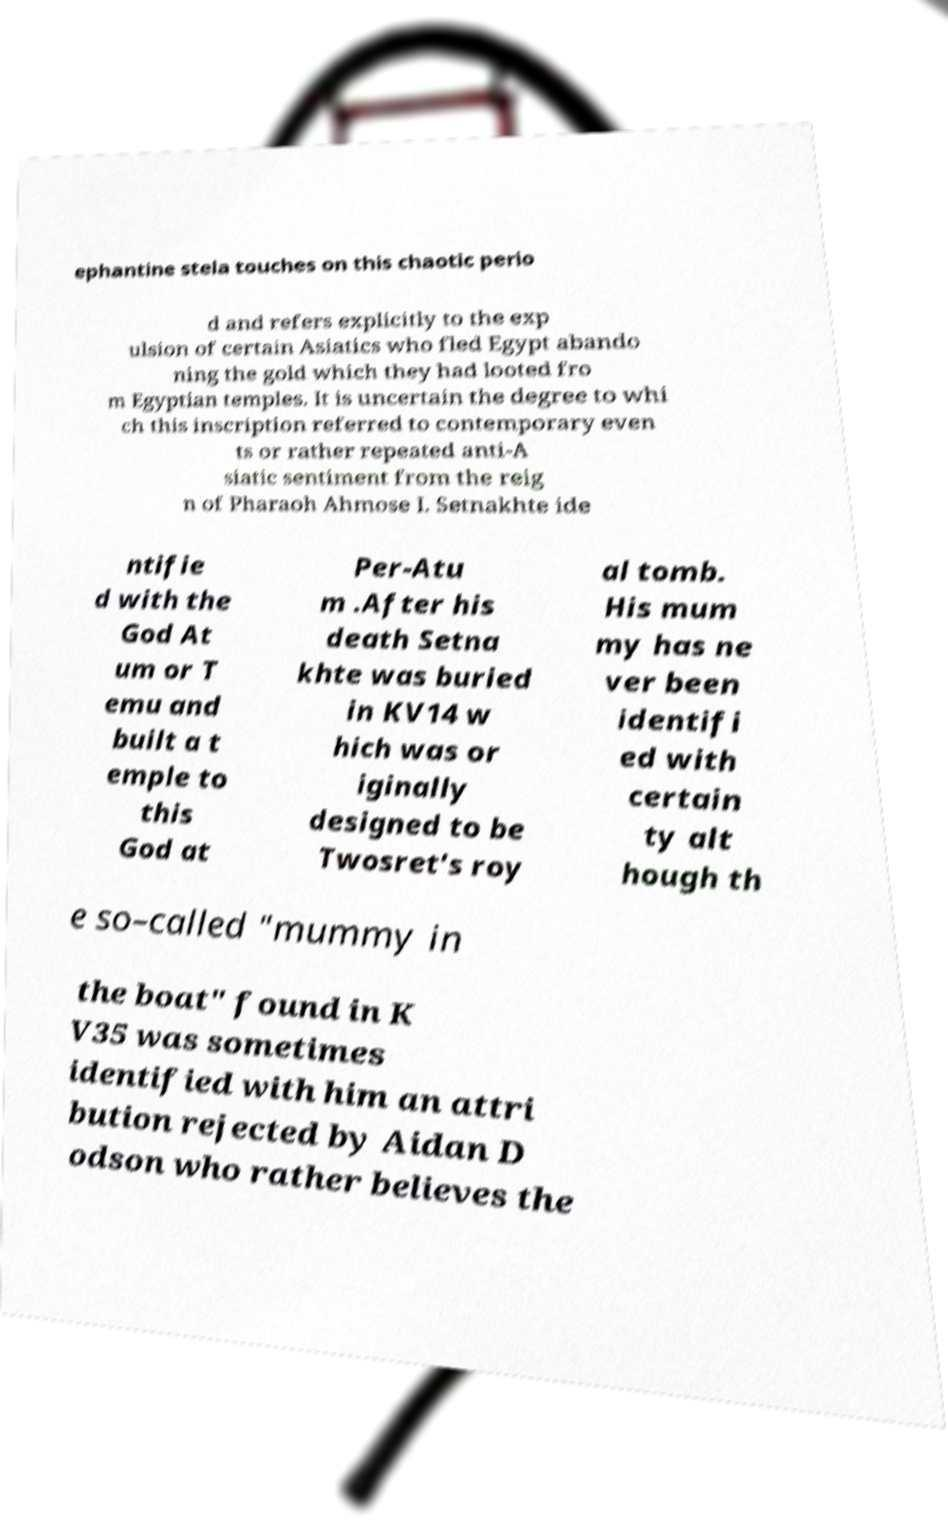Can you accurately transcribe the text from the provided image for me? ephantine stela touches on this chaotic perio d and refers explicitly to the exp ulsion of certain Asiatics who fled Egypt abando ning the gold which they had looted fro m Egyptian temples. It is uncertain the degree to whi ch this inscription referred to contemporary even ts or rather repeated anti-A siatic sentiment from the reig n of Pharaoh Ahmose I. Setnakhte ide ntifie d with the God At um or T emu and built a t emple to this God at Per-Atu m .After his death Setna khte was buried in KV14 w hich was or iginally designed to be Twosret's roy al tomb. His mum my has ne ver been identifi ed with certain ty alt hough th e so–called "mummy in the boat" found in K V35 was sometimes identified with him an attri bution rejected by Aidan D odson who rather believes the 